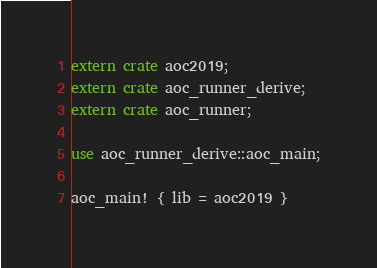Convert code to text. <code><loc_0><loc_0><loc_500><loc_500><_Rust_>extern crate aoc2019;
extern crate aoc_runner_derive;
extern crate aoc_runner;

use aoc_runner_derive::aoc_main;

aoc_main! { lib = aoc2019 }</code> 